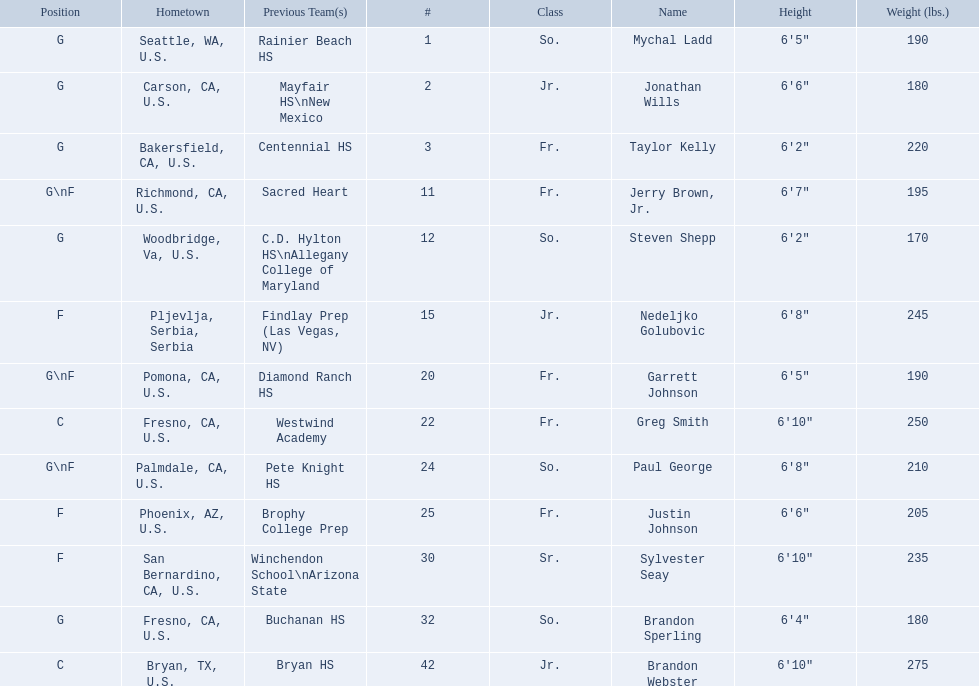What class was each team member in for the 2009-10 fresno state bulldogs? So., Jr., Fr., Fr., So., Jr., Fr., Fr., So., Fr., Sr., So., Jr. Which of these was outside of the us? Jr. Who was the player? Nedeljko Golubovic. 